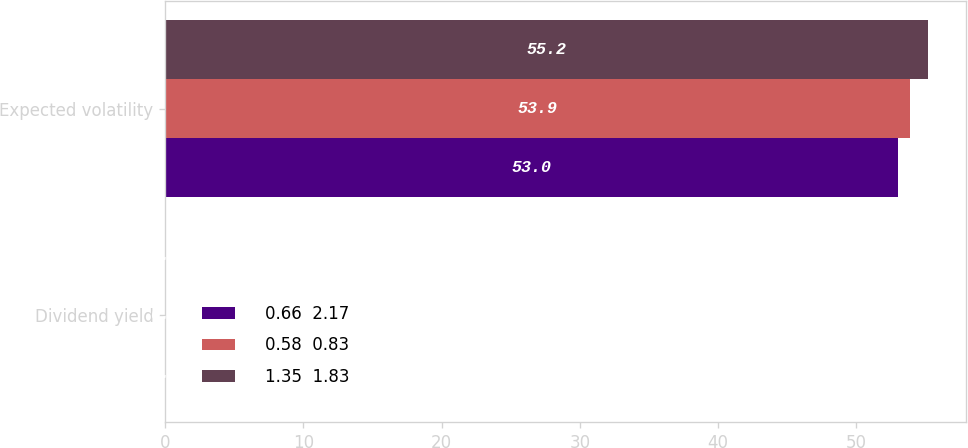<chart> <loc_0><loc_0><loc_500><loc_500><stacked_bar_chart><ecel><fcel>Dividend yield<fcel>Expected volatility<nl><fcel>0.66  2.17<fcel>0<fcel>53<nl><fcel>0.58  0.83<fcel>0<fcel>53.9<nl><fcel>1.35  1.83<fcel>0<fcel>55.2<nl></chart> 